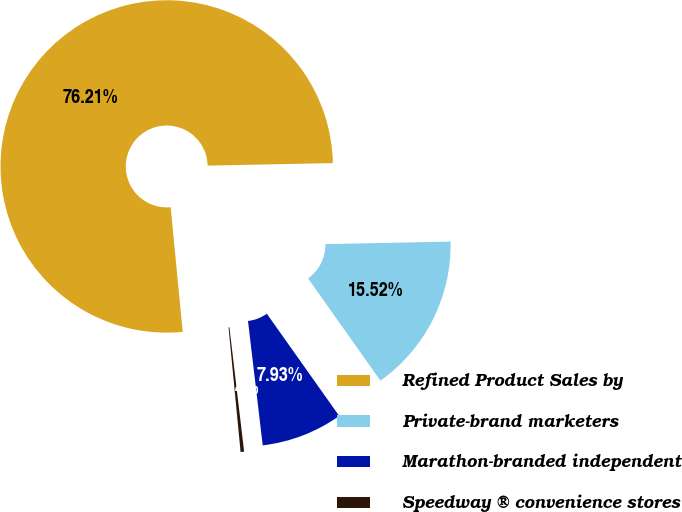Convert chart. <chart><loc_0><loc_0><loc_500><loc_500><pie_chart><fcel>Refined Product Sales by<fcel>Private-brand marketers<fcel>Marathon-branded independent<fcel>Speedway ® convenience stores<nl><fcel>76.22%<fcel>15.52%<fcel>7.93%<fcel>0.34%<nl></chart> 